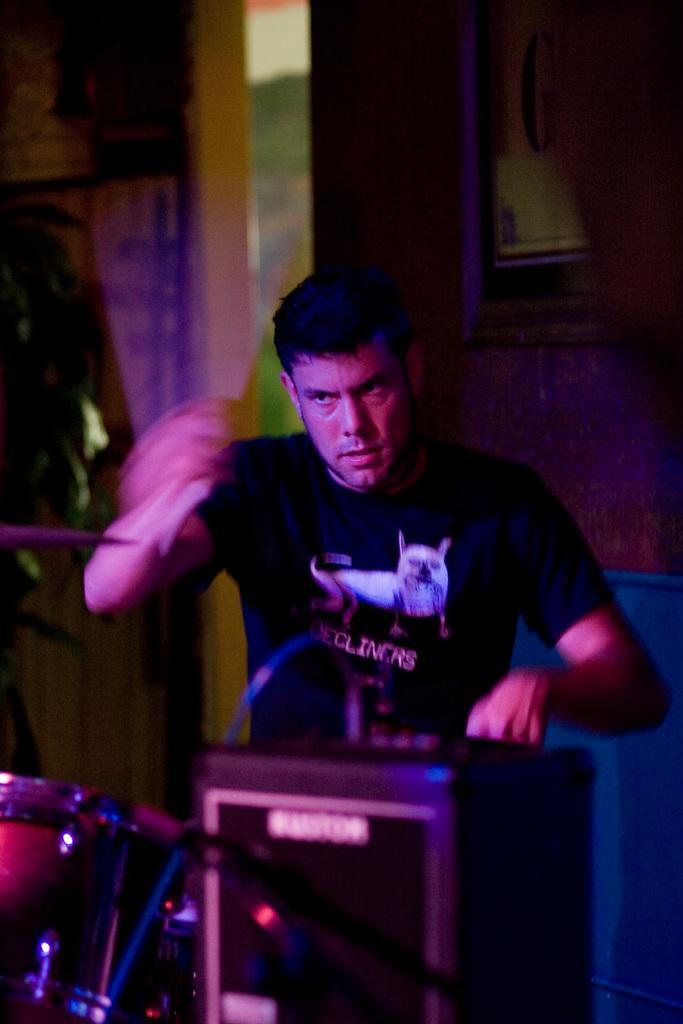Please provide a concise description of this image. In this image in the front there is an object which is black in colour. In the center there is a person sitting and there are musical instruments. In the background there is a plant and there is a wall and on the wall there is a frame. 